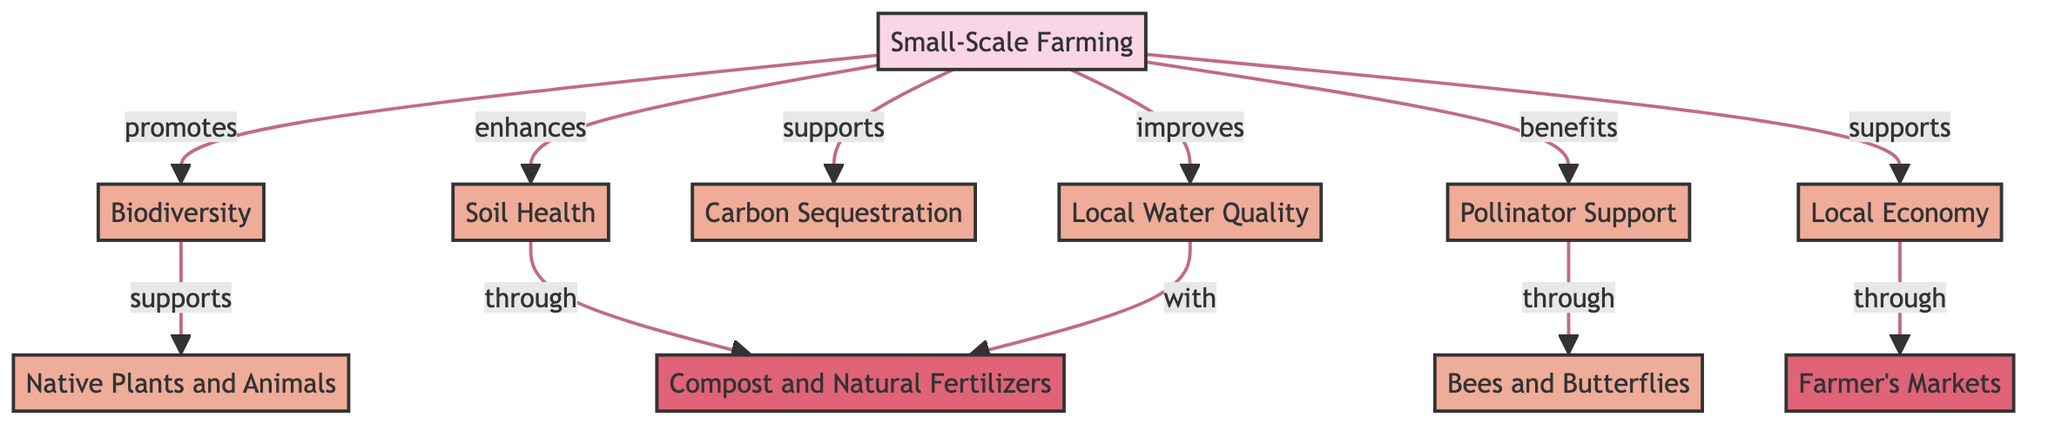What is the primary focus of the diagram? The primary focus of the diagram is "Small-Scale Farming," which is the central node and the starting point for the relationships shown in the flow chart.
Answer: Small-Scale Farming How many benefits are linked to small-scale farming? By counting the edges from the "Small-Scale Farming" node to the benefit nodes, we can see there are eight benefits listed, specifically biodiversity, native plants and animals, soil health, carbon sequestration, local water quality, pollinator support, local economy, and bees and butterflies.
Answer: Eight What method is associated with improving soil health? The diagram indicates that "Compost and Natural Fertilizers" is the method that enhances soil health, as shown by the connection from "Soil Health" to this method node in the flowchart.
Answer: Compost and Natural Fertilizers Which benefit directly supports native plants and animals? The diagram shows that "Biodiversity" directly supports "Native Plants and Animals," as this connection is indicated with a directed arrow.
Answer: Biodiversity How does small-scale farming contribute to the local economy? According to the flowchart, "Small-Scale Farming" benefits the "Local Economy" through the "Farmer's Markets" method, demonstrating a direct relationship between these nodes.
Answer: Through Farmer's Markets What is the relationship between soil health and local water quality? The diagram illustrates that "Soil Health" improves "Local Water Quality," connecting these two nodes with a directed arrow, indicating a supportive relationship.
Answer: Soil Health improves Local Water Quality What type of pollinators are supported by small-scale farming? The diagram specifies that "Bees and Butterflies" are the pollinator types that are supported by small-scale farming as indicated by the connection from the pollinator support node.
Answer: Bees and Butterflies How many methods are shown in the diagram? There are two methods depicted in the diagram: "Compost and Natural Fertilizers" and "Farmer's Markets," which are both connected to their respective benefits and the main node.
Answer: Two What role does carbon sequestration play in small-scale farming? The diagram indicates that "Carbon Sequestration" is one of the benefits supported by small-scale farming, illustrating the relationship that it has with the main farming node.
Answer: Benefit What aspect of biodiversity is highlighted in relation to small-scale farming? The diagram highlights that "Biodiversity" supports "Native Plants and Animals," showing a specific aspect of biodiversity inherent to small-scale farming efforts.
Answer: Native Plants and Animals 